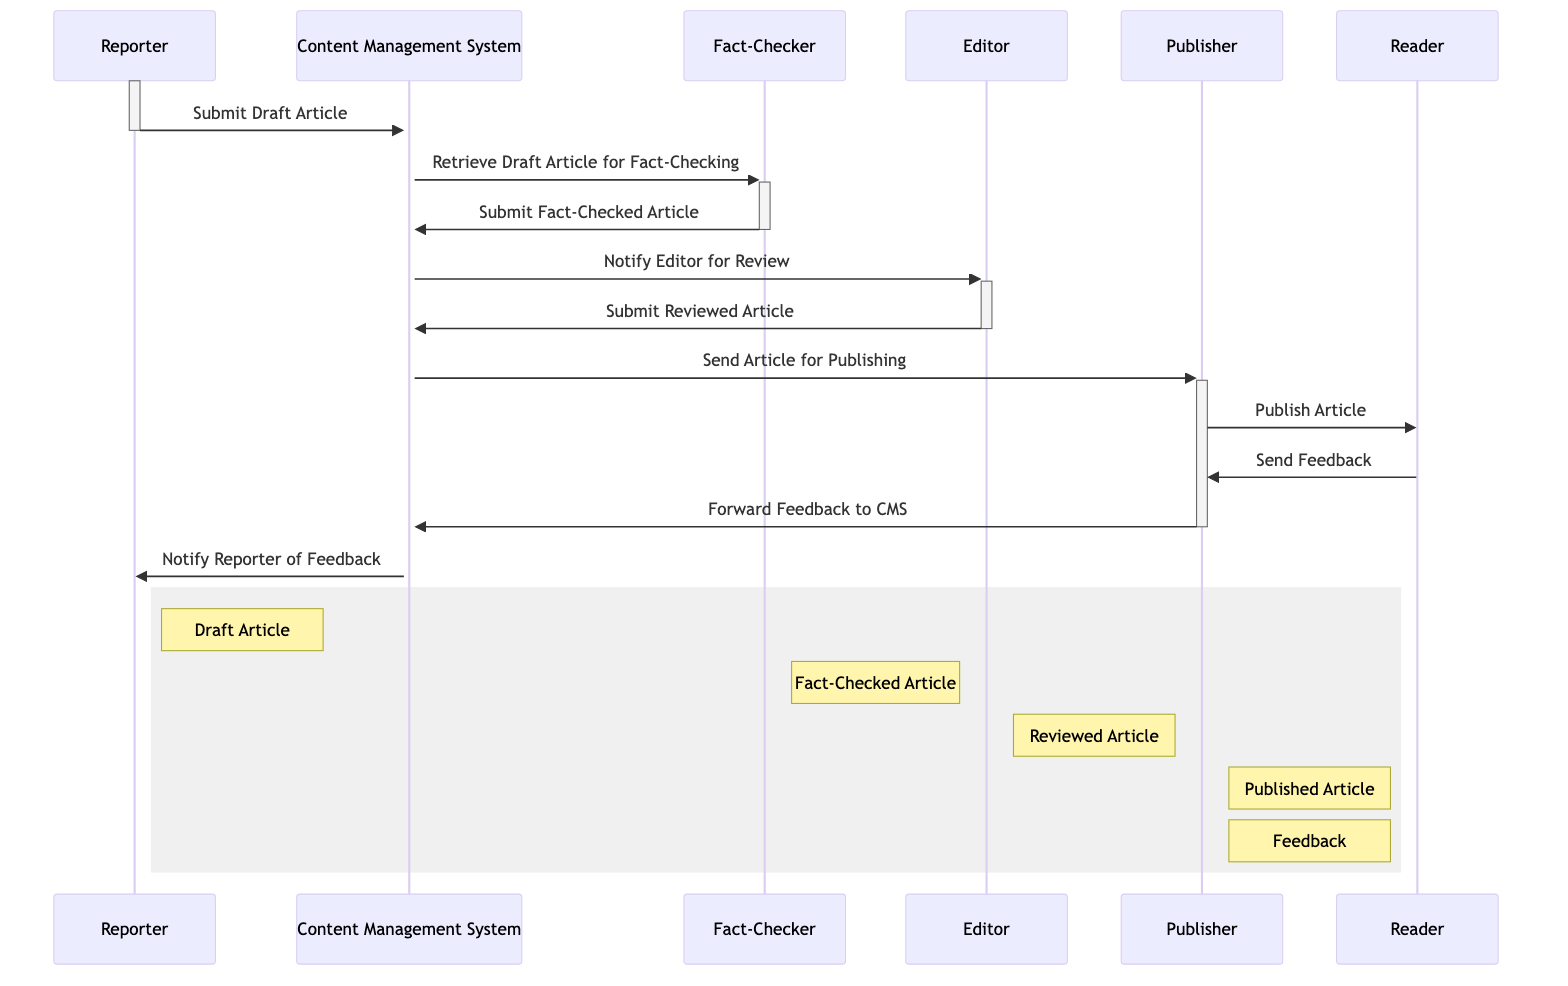What is the first action in the workflow? The first action in the workflow is initiated by the Reporter, who submits a draft article to the Content Management System. This is clearly indicated as the first message in the sequence.
Answer: Submit Draft Article Who receives the fact-checked article after it is submitted? After the fact-checked article is submitted by the Fact-Checker, it is received by the CMS, which is next in the sequence of interactions between actors.
Answer: CMS How many articles are created before publishing? In the workflow, three distinct articles are created before the final publishing: the Draft Article, the Fact-Checked Article, and the Reviewed Article. These are listed in the sequence of messages and the notes alongside the actors.
Answer: Three What triggers the notification to the Editor? The notification to the Editor is triggered by the CMS after it retrieves and receives the fact-checked article from the Fact-Checker, indicating that the article is ready for review.
Answer: Retrieve Draft Article for Fact-Checking What action occurs immediately after the Editor submits the Reviewed Article? Immediately after the Editor submits the Reviewed Article, the CMS sends the article for publishing to the Publisher. This follows directly in the sequence of messages.
Answer: Send Article for Publishing How is feedback communicated back to the Reporter? Feedback is communicated back to the Reporter after the Publisher receives feedback from the Reader, which the Publisher then forwards to the CMS. Finally, the CMS notifies the Reporter of the feedback. This shows the loop of communication back to the Reporter.
Answer: Notify Reporter of Feedback Which actor publishes the article? The Publisher is the actor responsible for publishing the article, as indicated by the message sent from the Publisher to the Reader in the diagram.
Answer: Publisher What roles are involved in verifying the article before publishing? The roles involved in verifying the article before publishing are the Fact-Checker and the Editor. The Fact-Checker checks the draft article, and the Editor reviews it before sending it to the Publisher.
Answer: Fact-Checker and Editor How many total actors participate in this workflow? There are six distinct actors participating in the workflow: Reporter, Content Management System, Fact-Checker, Editor, Publisher, and Reader.
Answer: Six 